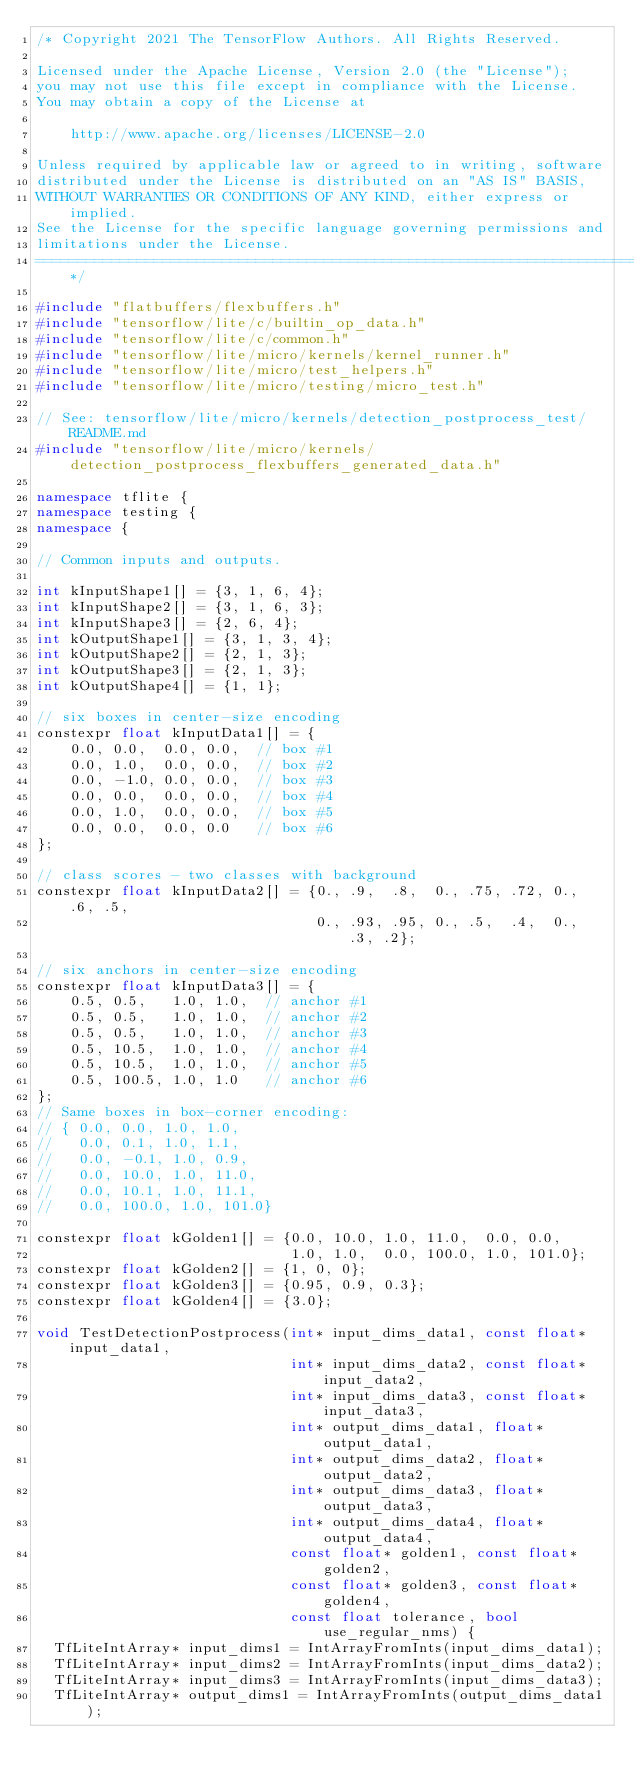<code> <loc_0><loc_0><loc_500><loc_500><_C++_>/* Copyright 2021 The TensorFlow Authors. All Rights Reserved.

Licensed under the Apache License, Version 2.0 (the "License");
you may not use this file except in compliance with the License.
You may obtain a copy of the License at

    http://www.apache.org/licenses/LICENSE-2.0

Unless required by applicable law or agreed to in writing, software
distributed under the License is distributed on an "AS IS" BASIS,
WITHOUT WARRANTIES OR CONDITIONS OF ANY KIND, either express or implied.
See the License for the specific language governing permissions and
limitations under the License.
==============================================================================*/

#include "flatbuffers/flexbuffers.h"
#include "tensorflow/lite/c/builtin_op_data.h"
#include "tensorflow/lite/c/common.h"
#include "tensorflow/lite/micro/kernels/kernel_runner.h"
#include "tensorflow/lite/micro/test_helpers.h"
#include "tensorflow/lite/micro/testing/micro_test.h"

// See: tensorflow/lite/micro/kernels/detection_postprocess_test/README.md
#include "tensorflow/lite/micro/kernels/detection_postprocess_flexbuffers_generated_data.h"

namespace tflite {
namespace testing {
namespace {

// Common inputs and outputs.

int kInputShape1[] = {3, 1, 6, 4};
int kInputShape2[] = {3, 1, 6, 3};
int kInputShape3[] = {2, 6, 4};
int kOutputShape1[] = {3, 1, 3, 4};
int kOutputShape2[] = {2, 1, 3};
int kOutputShape3[] = {2, 1, 3};
int kOutputShape4[] = {1, 1};

// six boxes in center-size encoding
constexpr float kInputData1[] = {
    0.0, 0.0,  0.0, 0.0,  // box #1
    0.0, 1.0,  0.0, 0.0,  // box #2
    0.0, -1.0, 0.0, 0.0,  // box #3
    0.0, 0.0,  0.0, 0.0,  // box #4
    0.0, 1.0,  0.0, 0.0,  // box #5
    0.0, 0.0,  0.0, 0.0   // box #6
};

// class scores - two classes with background
constexpr float kInputData2[] = {0., .9,  .8,  0., .75, .72, 0., .6, .5,
                                 0., .93, .95, 0., .5,  .4,  0., .3, .2};

// six anchors in center-size encoding
constexpr float kInputData3[] = {
    0.5, 0.5,   1.0, 1.0,  // anchor #1
    0.5, 0.5,   1.0, 1.0,  // anchor #2
    0.5, 0.5,   1.0, 1.0,  // anchor #3
    0.5, 10.5,  1.0, 1.0,  // anchor #4
    0.5, 10.5,  1.0, 1.0,  // anchor #5
    0.5, 100.5, 1.0, 1.0   // anchor #6
};
// Same boxes in box-corner encoding:
// { 0.0, 0.0, 1.0, 1.0,
//   0.0, 0.1, 1.0, 1.1,
//   0.0, -0.1, 1.0, 0.9,
//   0.0, 10.0, 1.0, 11.0,
//   0.0, 10.1, 1.0, 11.1,
//   0.0, 100.0, 1.0, 101.0}

constexpr float kGolden1[] = {0.0, 10.0, 1.0, 11.0,  0.0, 0.0,
                              1.0, 1.0,  0.0, 100.0, 1.0, 101.0};
constexpr float kGolden2[] = {1, 0, 0};
constexpr float kGolden3[] = {0.95, 0.9, 0.3};
constexpr float kGolden4[] = {3.0};

void TestDetectionPostprocess(int* input_dims_data1, const float* input_data1,
                              int* input_dims_data2, const float* input_data2,
                              int* input_dims_data3, const float* input_data3,
                              int* output_dims_data1, float* output_data1,
                              int* output_dims_data2, float* output_data2,
                              int* output_dims_data3, float* output_data3,
                              int* output_dims_data4, float* output_data4,
                              const float* golden1, const float* golden2,
                              const float* golden3, const float* golden4,
                              const float tolerance, bool use_regular_nms) {
  TfLiteIntArray* input_dims1 = IntArrayFromInts(input_dims_data1);
  TfLiteIntArray* input_dims2 = IntArrayFromInts(input_dims_data2);
  TfLiteIntArray* input_dims3 = IntArrayFromInts(input_dims_data3);
  TfLiteIntArray* output_dims1 = IntArrayFromInts(output_dims_data1);</code> 